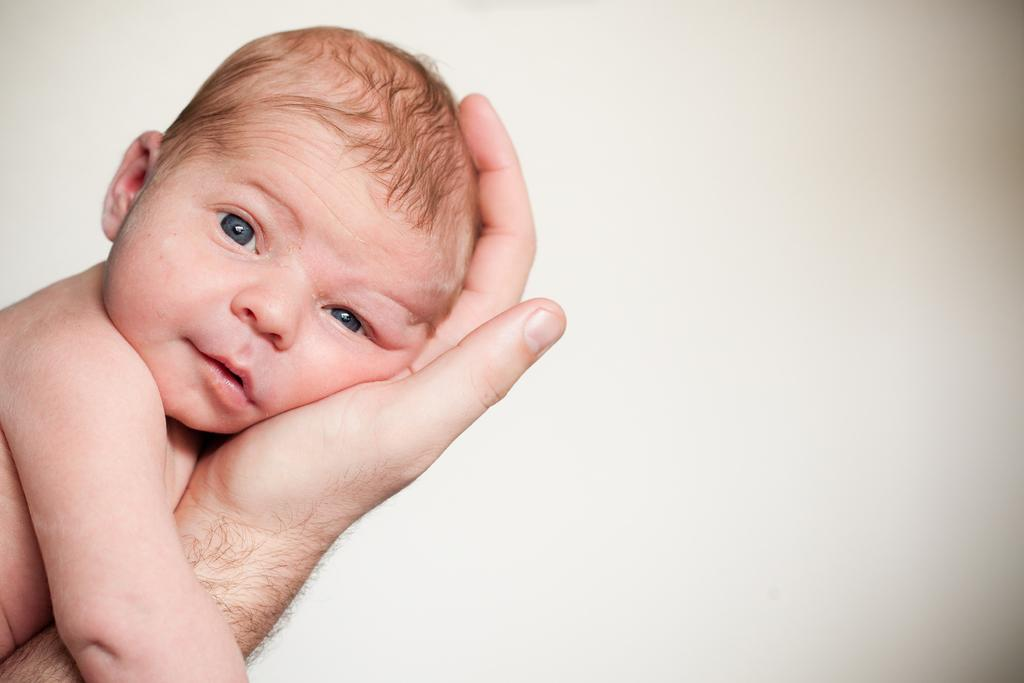What is the person's hand doing in the image? There is a person's hand holding a baby in the image. What can be seen in the background of the image? There is a wall in the background of the image. What type of division is being performed on the baby in the image? There is no division being performed on the baby in the image; the person's hand is simply holding the baby. 